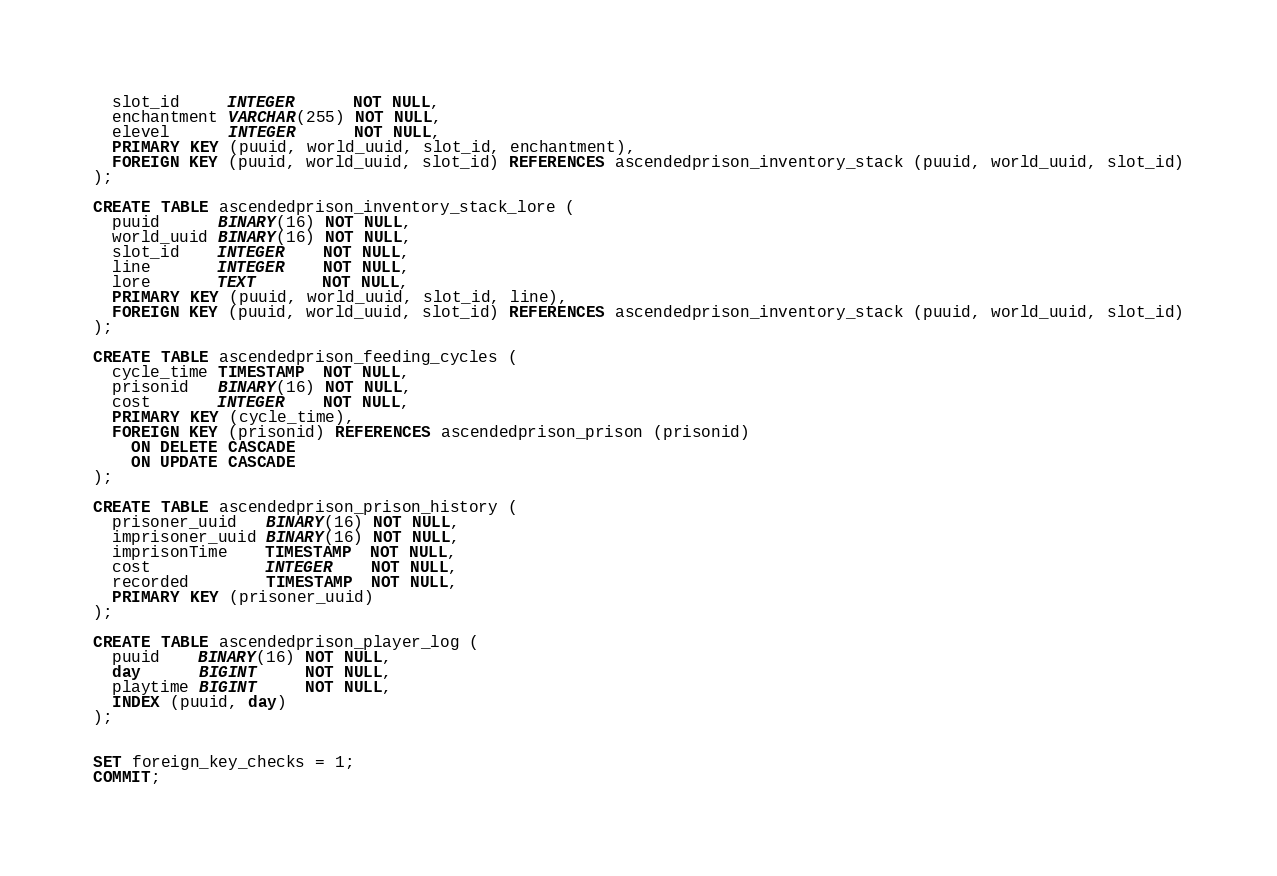<code> <loc_0><loc_0><loc_500><loc_500><_SQL_>  slot_id     INTEGER      NOT NULL,
  enchantment VARCHAR(255) NOT NULL,
  elevel      INTEGER      NOT NULL,
  PRIMARY KEY (puuid, world_uuid, slot_id, enchantment),
  FOREIGN KEY (puuid, world_uuid, slot_id) REFERENCES ascendedprison_inventory_stack (puuid, world_uuid, slot_id)
);

CREATE TABLE ascendedprison_inventory_stack_lore (
  puuid      BINARY(16) NOT NULL,
  world_uuid BINARY(16) NOT NULL,
  slot_id    INTEGER    NOT NULL,
  line       INTEGER    NOT NULL,
  lore       TEXT       NOT NULL,
  PRIMARY KEY (puuid, world_uuid, slot_id, line),
  FOREIGN KEY (puuid, world_uuid, slot_id) REFERENCES ascendedprison_inventory_stack (puuid, world_uuid, slot_id)
);

CREATE TABLE ascendedprison_feeding_cycles (
  cycle_time TIMESTAMP  NOT NULL,
  prisonid   BINARY(16) NOT NULL,
  cost       INTEGER    NOT NULL,
  PRIMARY KEY (cycle_time),
  FOREIGN KEY (prisonid) REFERENCES ascendedprison_prison (prisonid)
    ON DELETE CASCADE
    ON UPDATE CASCADE
);

CREATE TABLE ascendedprison_prison_history (
  prisoner_uuid   BINARY(16) NOT NULL,
  imprisoner_uuid BINARY(16) NOT NULL,
  imprisonTime    TIMESTAMP  NOT NULL,
  cost            INTEGER    NOT NULL,
  recorded        TIMESTAMP  NOT NULL,
  PRIMARY KEY (prisoner_uuid)
);

CREATE TABLE ascendedprison_player_log (
  puuid    BINARY(16) NOT NULL,
  day      BIGINT     NOT NULL,
  playtime BIGINT     NOT NULL,
  INDEX (puuid, day)
);


SET foreign_key_checks = 1;
COMMIT;</code> 